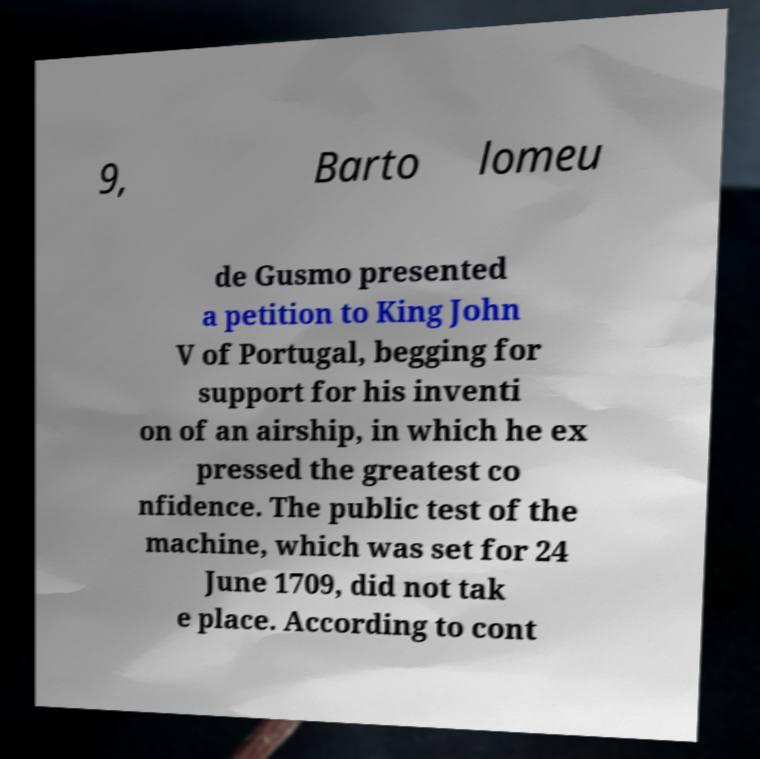Could you extract and type out the text from this image? 9, Barto lomeu de Gusmo presented a petition to King John V of Portugal, begging for support for his inventi on of an airship, in which he ex pressed the greatest co nfidence. The public test of the machine, which was set for 24 June 1709, did not tak e place. According to cont 